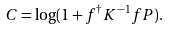Convert formula to latex. <formula><loc_0><loc_0><loc_500><loc_500>C = \log ( 1 + { f ^ { \dagger } K ^ { - 1 } f } P ) .</formula> 